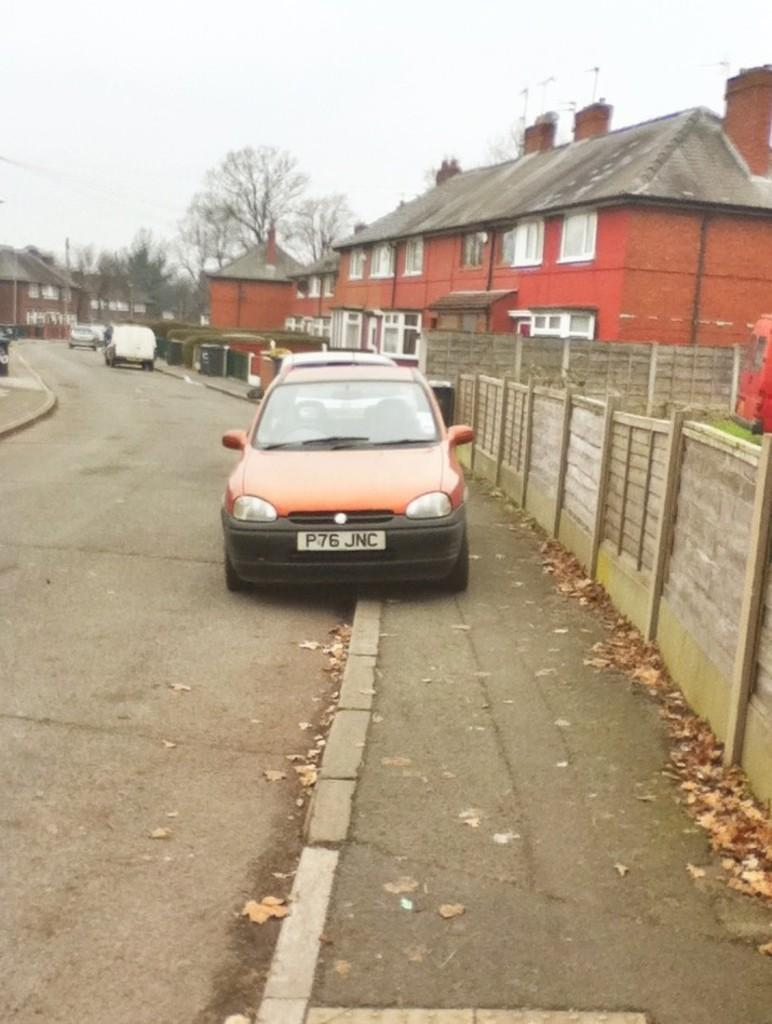What is happening on the road in the image? There are vehicles on the road in the image. What can be seen in the distance behind the vehicles? There are buildings, trees, plants, and the sky visible in the background of the image. What type of fruit is hanging from the trees in the image? There is no fruit visible in the image; only trees are present in the background. 